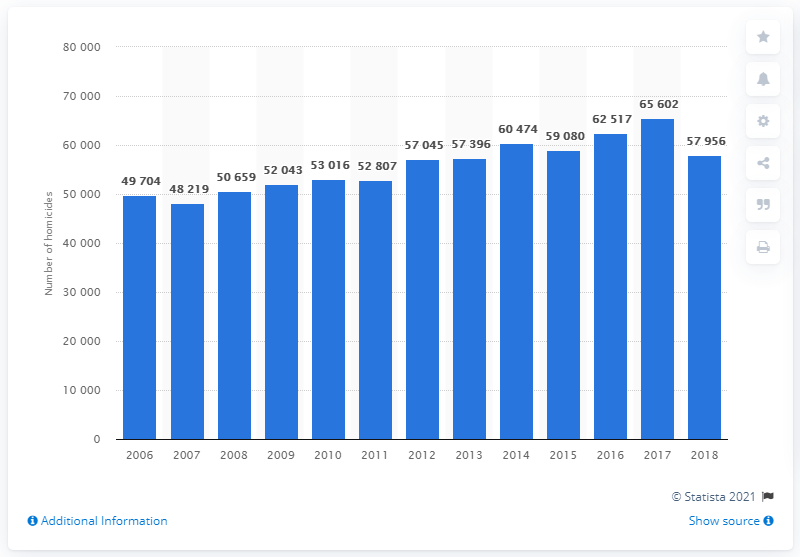Specify some key components in this picture. In 2018, a total of 57,956 homicides were reported in Brazil. 